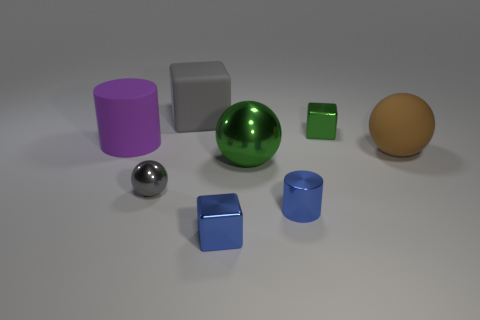Is there a pattern to the arrangement of the objects? The objects do not seem to be arranged in any clear pattern. Their placement appears random with variations in distance and alignment, suggesting no intentional sequencing or symmetry. 